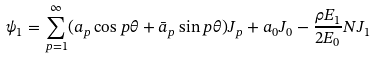<formula> <loc_0><loc_0><loc_500><loc_500>\psi _ { 1 } = \sum _ { p = 1 } ^ { \infty } ( a _ { p } \cos p \theta + \bar { a } _ { p } \sin p \theta ) J _ { p } + a _ { 0 } J _ { 0 } - \frac { \rho E _ { 1 } } { 2 E _ { 0 } } N J _ { 1 }</formula> 